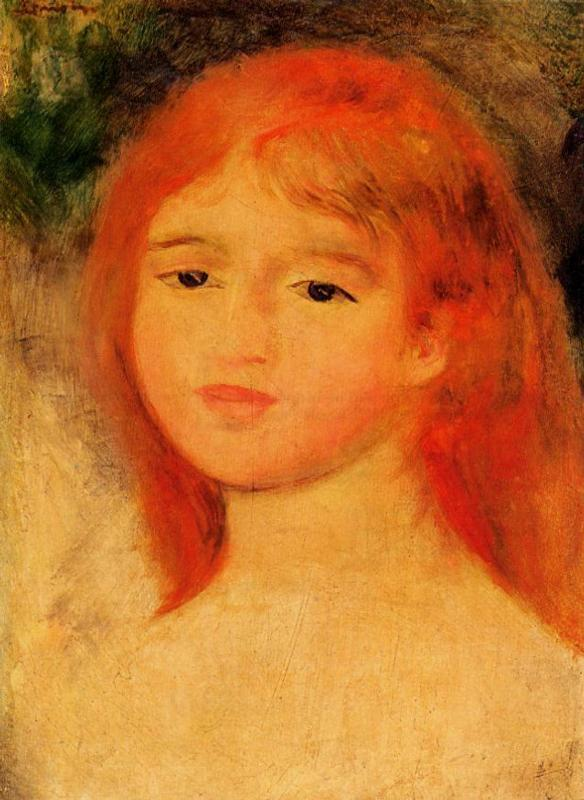How does the use of color influence the perception of the girl's character in this artwork? The vivid orange-red of the girl's hair and the subtle blush on her cheeks set against the muted background of greens and blues create a striking contrast, which may be interpreted as highlighting her youth and vivacity. The warmth of her hair color suggests a fiery or spirited nature, while the soft pastels of her complexion and surroundings might hint at gentleness and sensitivity. Through this interplay of colors, the artist seems to convey the complexities of her personality. 